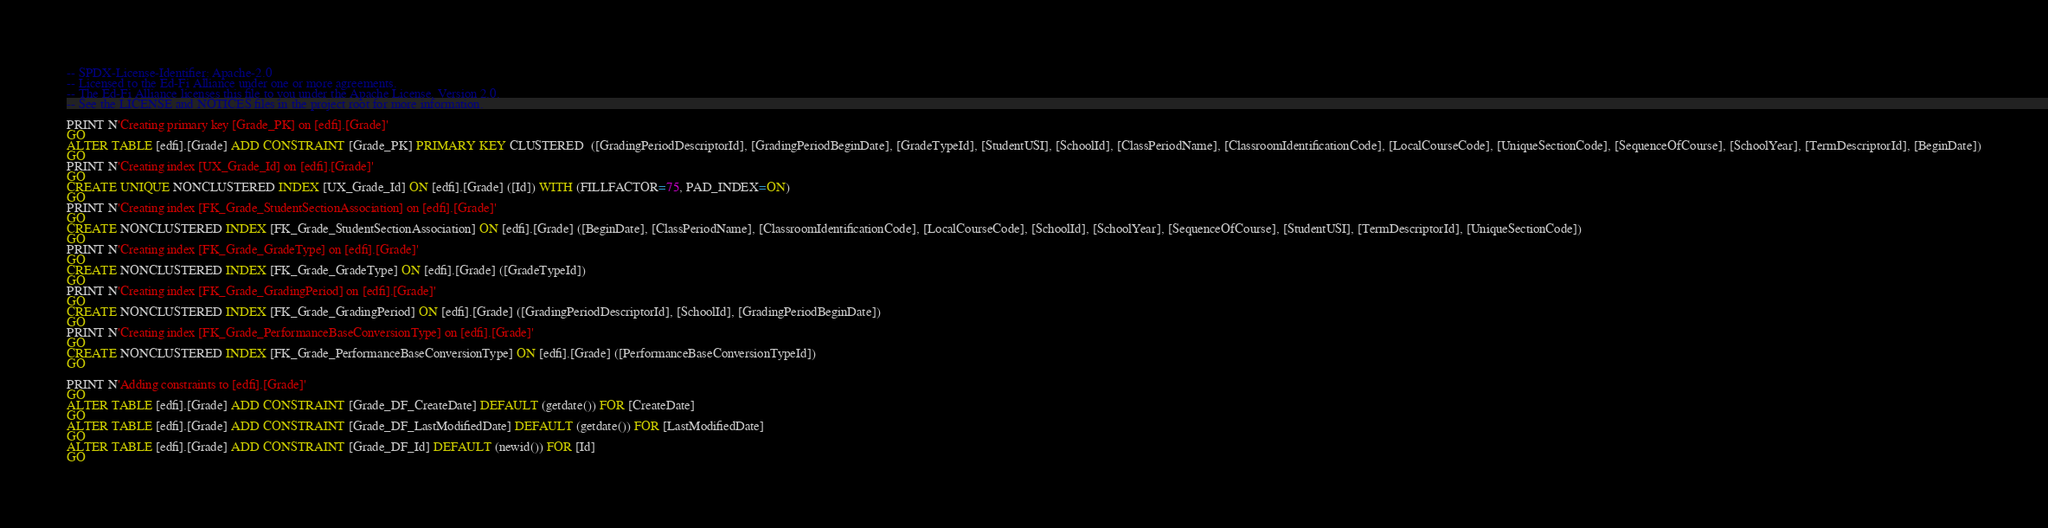<code> <loc_0><loc_0><loc_500><loc_500><_SQL_>-- SPDX-License-Identifier: Apache-2.0
-- Licensed to the Ed-Fi Alliance under one or more agreements.
-- The Ed-Fi Alliance licenses this file to you under the Apache License, Version 2.0.
-- See the LICENSE and NOTICES files in the project root for more information.

PRINT N'Creating primary key [Grade_PK] on [edfi].[Grade]'
GO
ALTER TABLE [edfi].[Grade] ADD CONSTRAINT [Grade_PK] PRIMARY KEY CLUSTERED  ([GradingPeriodDescriptorId], [GradingPeriodBeginDate], [GradeTypeId], [StudentUSI], [SchoolId], [ClassPeriodName], [ClassroomIdentificationCode], [LocalCourseCode], [UniqueSectionCode], [SequenceOfCourse], [SchoolYear], [TermDescriptorId], [BeginDate])
GO
PRINT N'Creating index [UX_Grade_Id] on [edfi].[Grade]'
GO
CREATE UNIQUE NONCLUSTERED INDEX [UX_Grade_Id] ON [edfi].[Grade] ([Id]) WITH (FILLFACTOR=75, PAD_INDEX=ON)
GO
PRINT N'Creating index [FK_Grade_StudentSectionAssociation] on [edfi].[Grade]'
GO
CREATE NONCLUSTERED INDEX [FK_Grade_StudentSectionAssociation] ON [edfi].[Grade] ([BeginDate], [ClassPeriodName], [ClassroomIdentificationCode], [LocalCourseCode], [SchoolId], [SchoolYear], [SequenceOfCourse], [StudentUSI], [TermDescriptorId], [UniqueSectionCode])
GO
PRINT N'Creating index [FK_Grade_GradeType] on [edfi].[Grade]'
GO
CREATE NONCLUSTERED INDEX [FK_Grade_GradeType] ON [edfi].[Grade] ([GradeTypeId])
GO
PRINT N'Creating index [FK_Grade_GradingPeriod] on [edfi].[Grade]'
GO
CREATE NONCLUSTERED INDEX [FK_Grade_GradingPeriod] ON [edfi].[Grade] ([GradingPeriodDescriptorId], [SchoolId], [GradingPeriodBeginDate])
GO
PRINT N'Creating index [FK_Grade_PerformanceBaseConversionType] on [edfi].[Grade]'
GO
CREATE NONCLUSTERED INDEX [FK_Grade_PerformanceBaseConversionType] ON [edfi].[Grade] ([PerformanceBaseConversionTypeId])
GO

PRINT N'Adding constraints to [edfi].[Grade]'
GO
ALTER TABLE [edfi].[Grade] ADD CONSTRAINT [Grade_DF_CreateDate] DEFAULT (getdate()) FOR [CreateDate]
GO
ALTER TABLE [edfi].[Grade] ADD CONSTRAINT [Grade_DF_LastModifiedDate] DEFAULT (getdate()) FOR [LastModifiedDate]
GO
ALTER TABLE [edfi].[Grade] ADD CONSTRAINT [Grade_DF_Id] DEFAULT (newid()) FOR [Id]
GO

</code> 